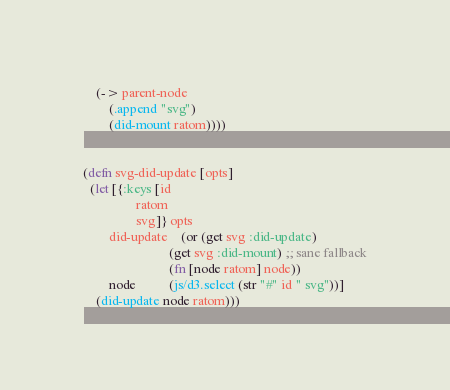Convert code to text. <code><loc_0><loc_0><loc_500><loc_500><_Clojure_>    (-> parent-node
        (.append "svg")
        (did-mount ratom))))


(defn svg-did-update [opts]
  (let [{:keys [id
                ratom
                svg]} opts
        did-update    (or (get svg :did-update)
                          (get svg :did-mount) ;; sane fallback
                          (fn [node ratom] node))
        node          (js/d3.select (str "#" id " svg"))]
    (did-update node ratom)))
</code> 